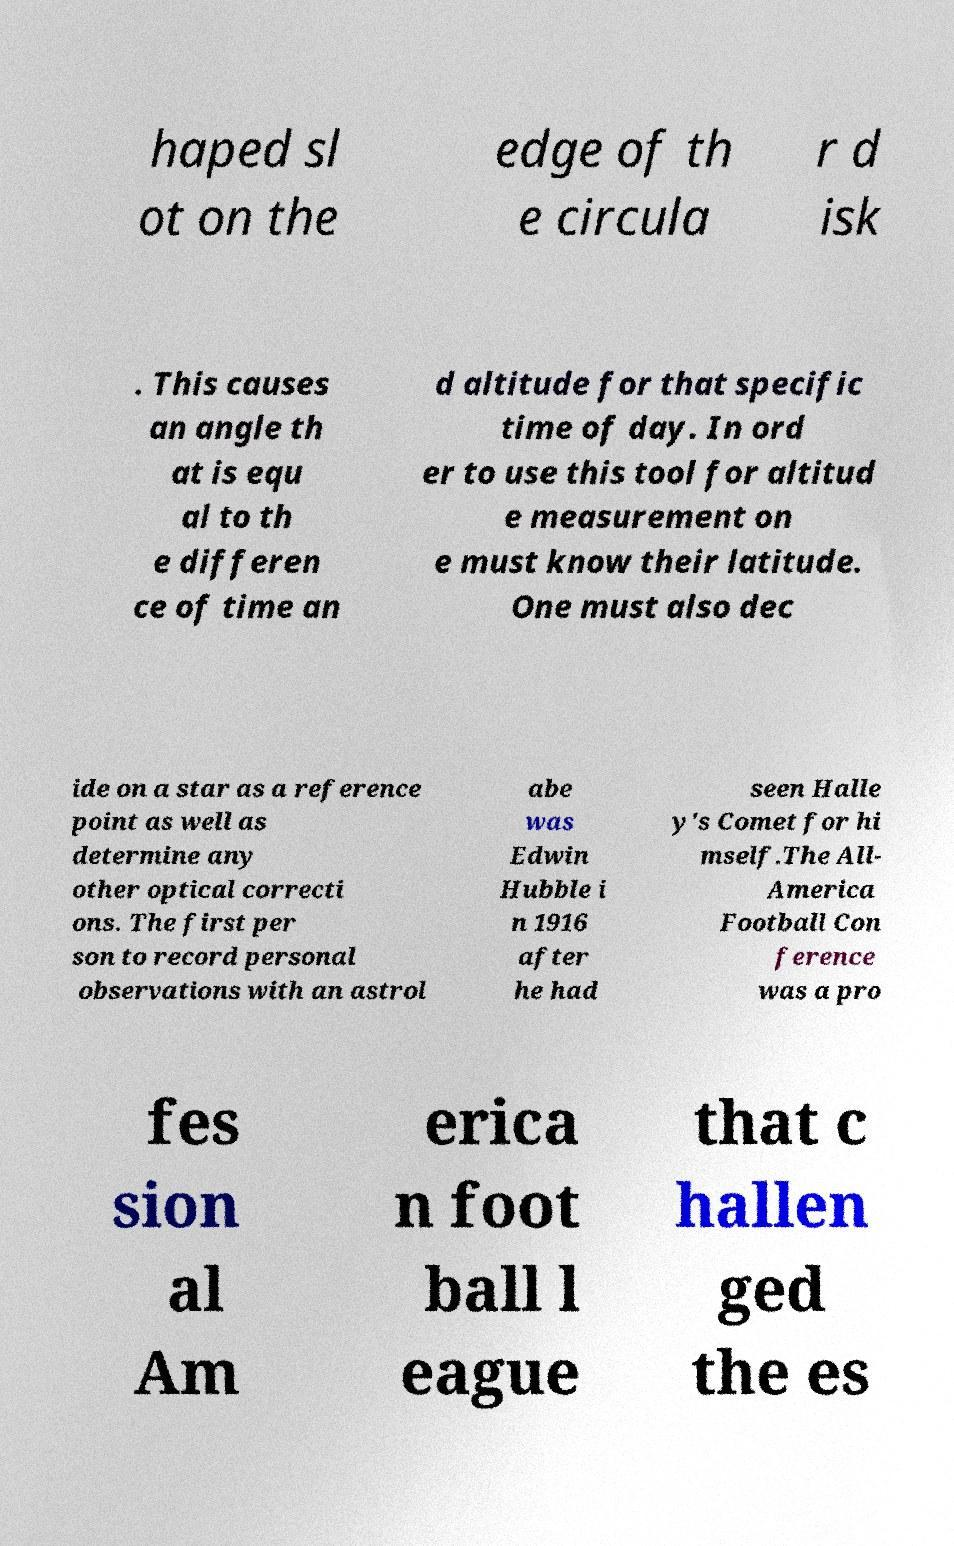Please identify and transcribe the text found in this image. haped sl ot on the edge of th e circula r d isk . This causes an angle th at is equ al to th e differen ce of time an d altitude for that specific time of day. In ord er to use this tool for altitud e measurement on e must know their latitude. One must also dec ide on a star as a reference point as well as determine any other optical correcti ons. The first per son to record personal observations with an astrol abe was Edwin Hubble i n 1916 after he had seen Halle y's Comet for hi mself.The All- America Football Con ference was a pro fes sion al Am erica n foot ball l eague that c hallen ged the es 